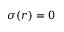Convert formula to latex. <formula><loc_0><loc_0><loc_500><loc_500>\sigma ( r ) = 0</formula> 